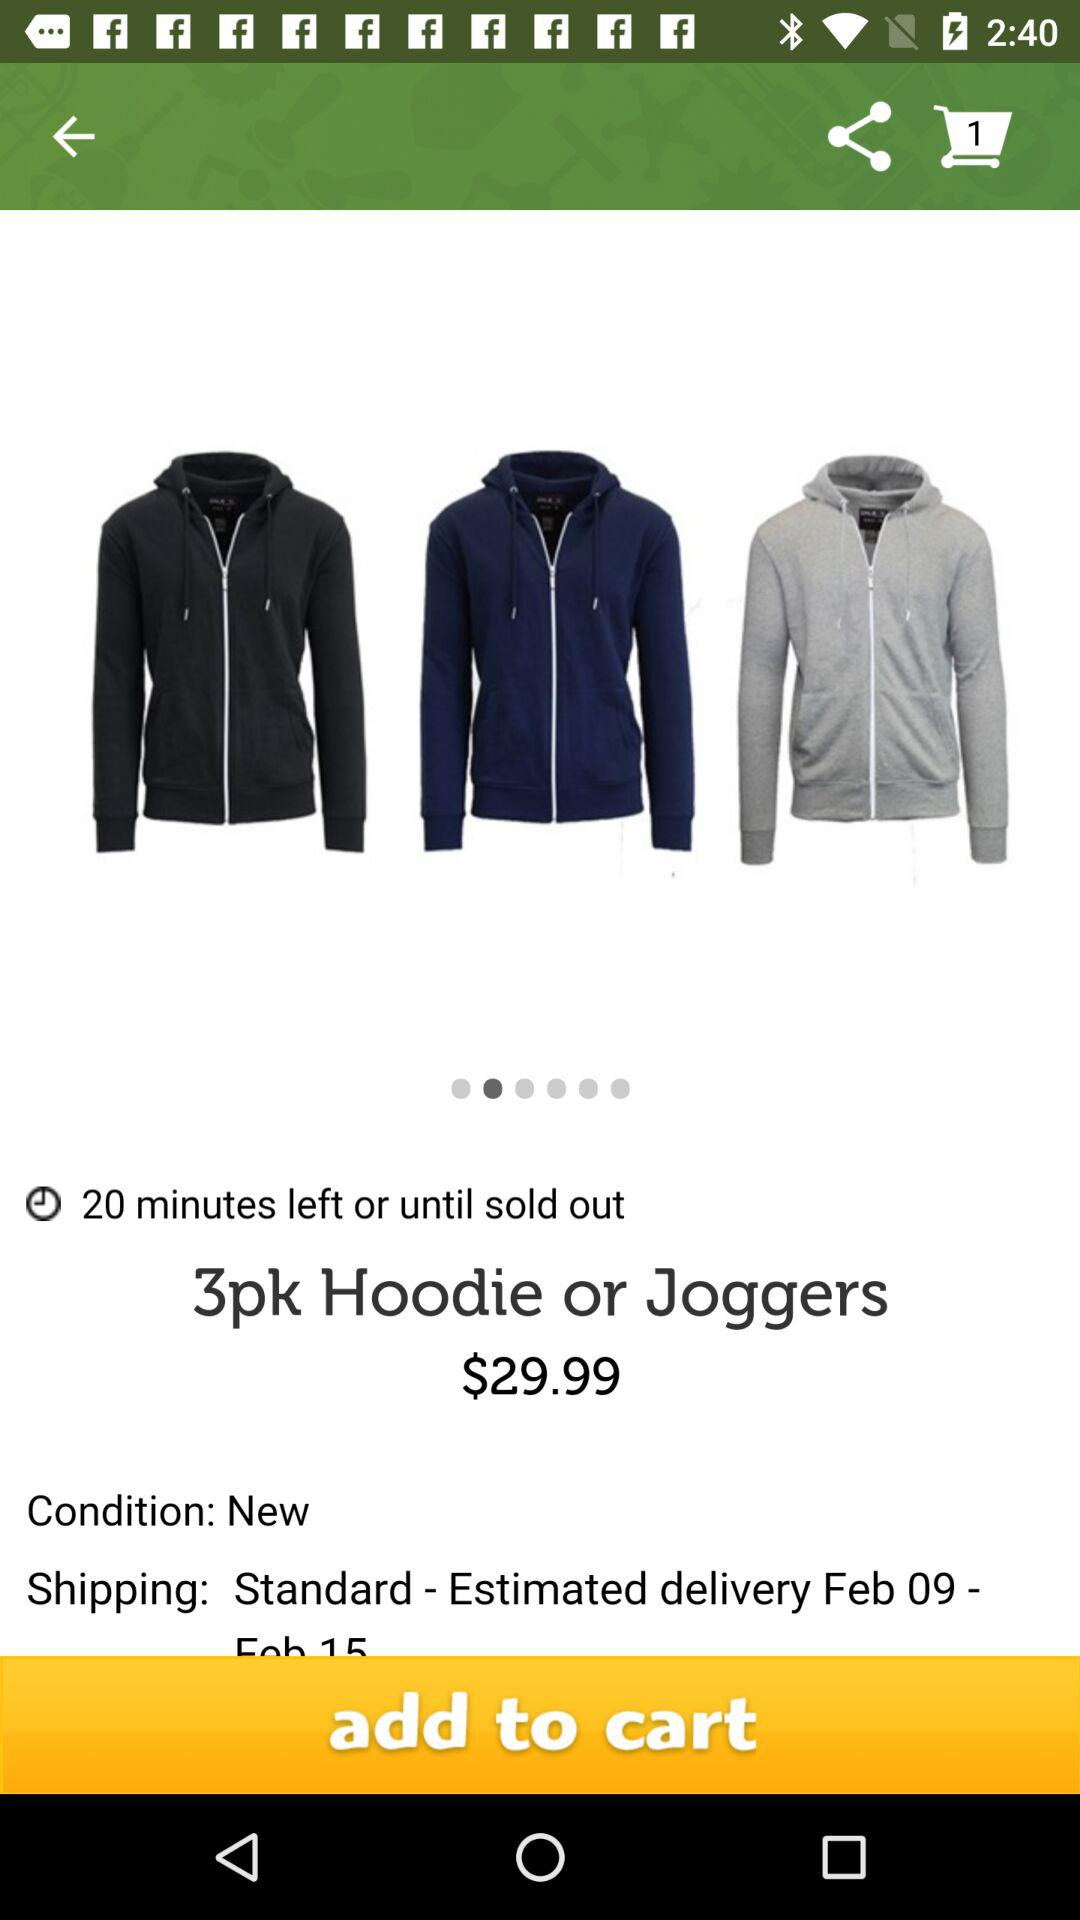What is the count of items in the cart? The count of items in the cart is 1. 